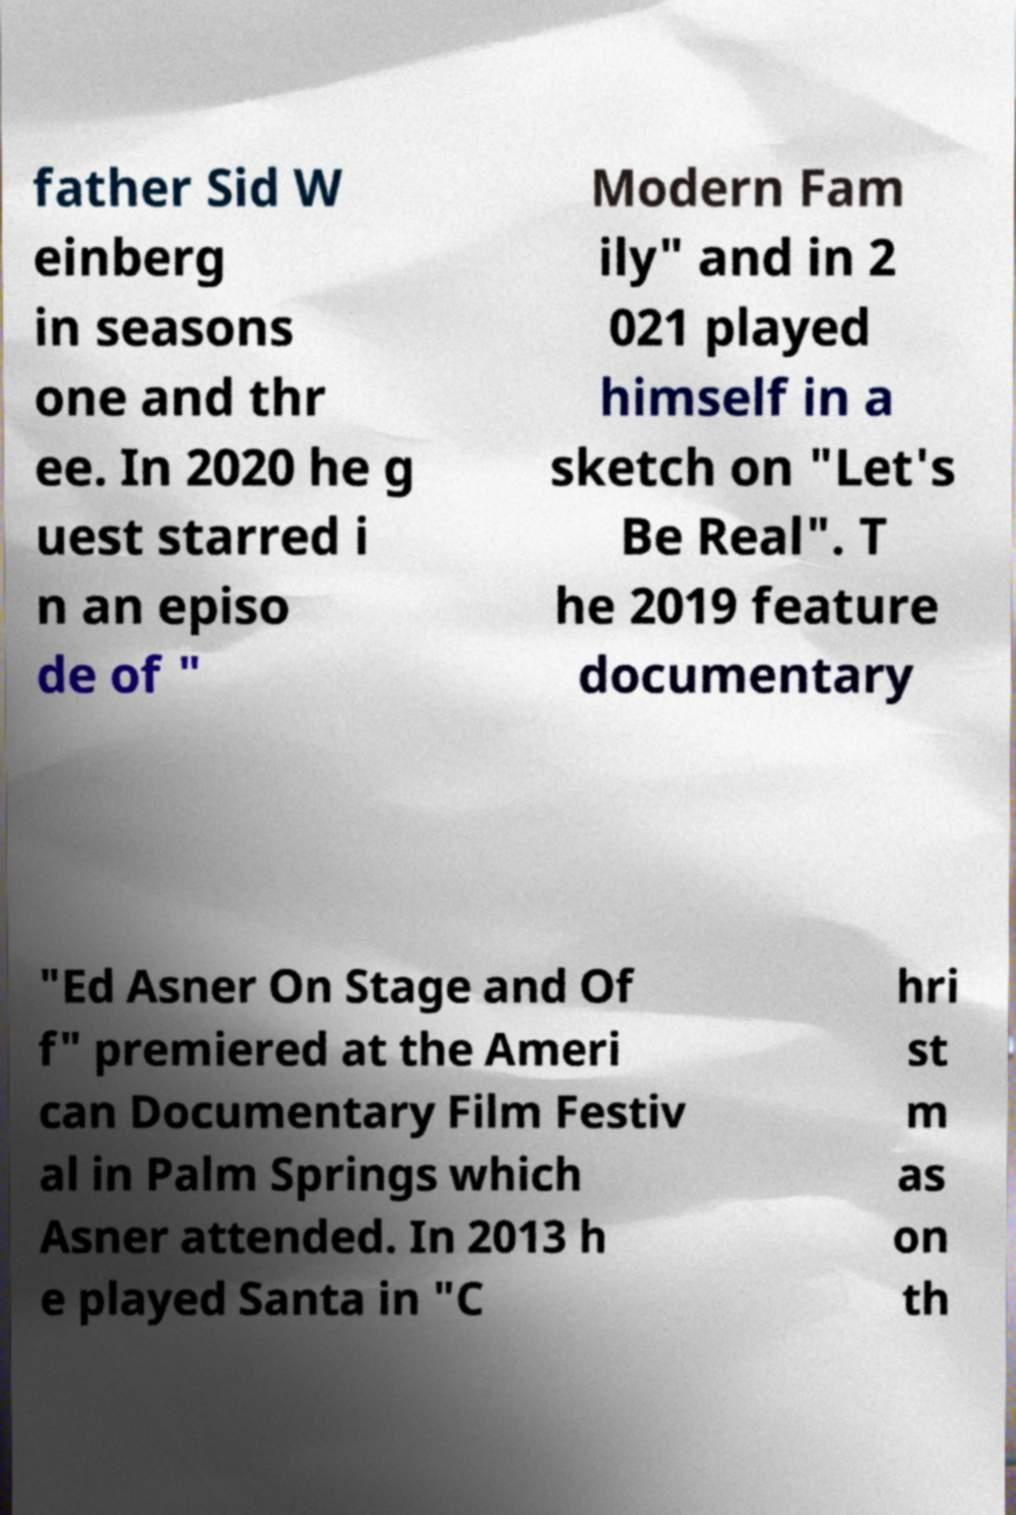Please identify and transcribe the text found in this image. father Sid W einberg in seasons one and thr ee. In 2020 he g uest starred i n an episo de of " Modern Fam ily" and in 2 021 played himself in a sketch on "Let's Be Real". T he 2019 feature documentary "Ed Asner On Stage and Of f" premiered at the Ameri can Documentary Film Festiv al in Palm Springs which Asner attended. In 2013 h e played Santa in "C hri st m as on th 